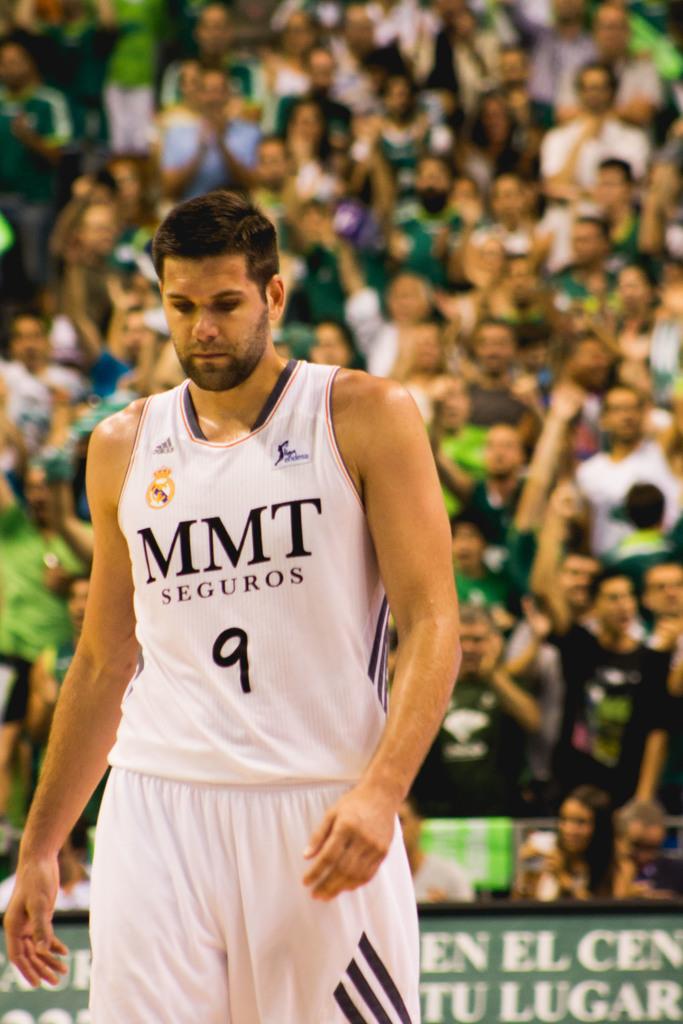What is the man's basketball number?
Your response must be concise. 9. What team is the player on?
Make the answer very short. Mmt seguros. 